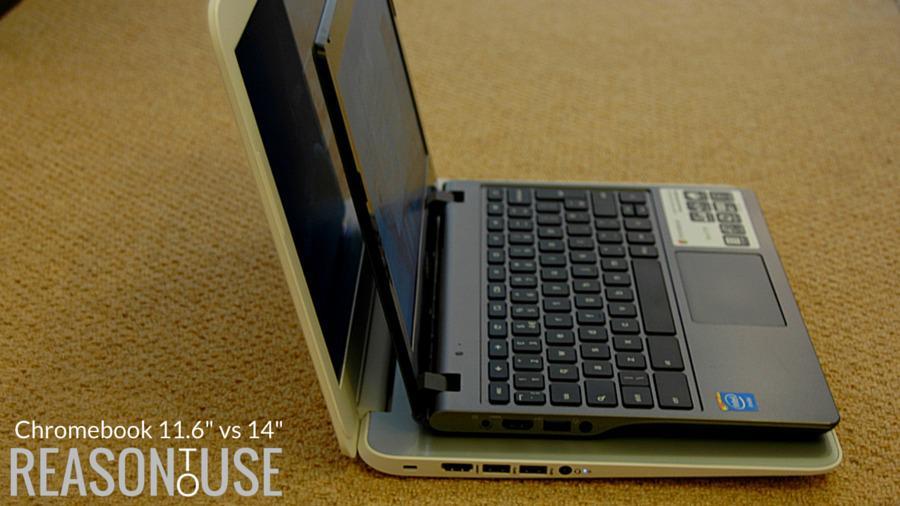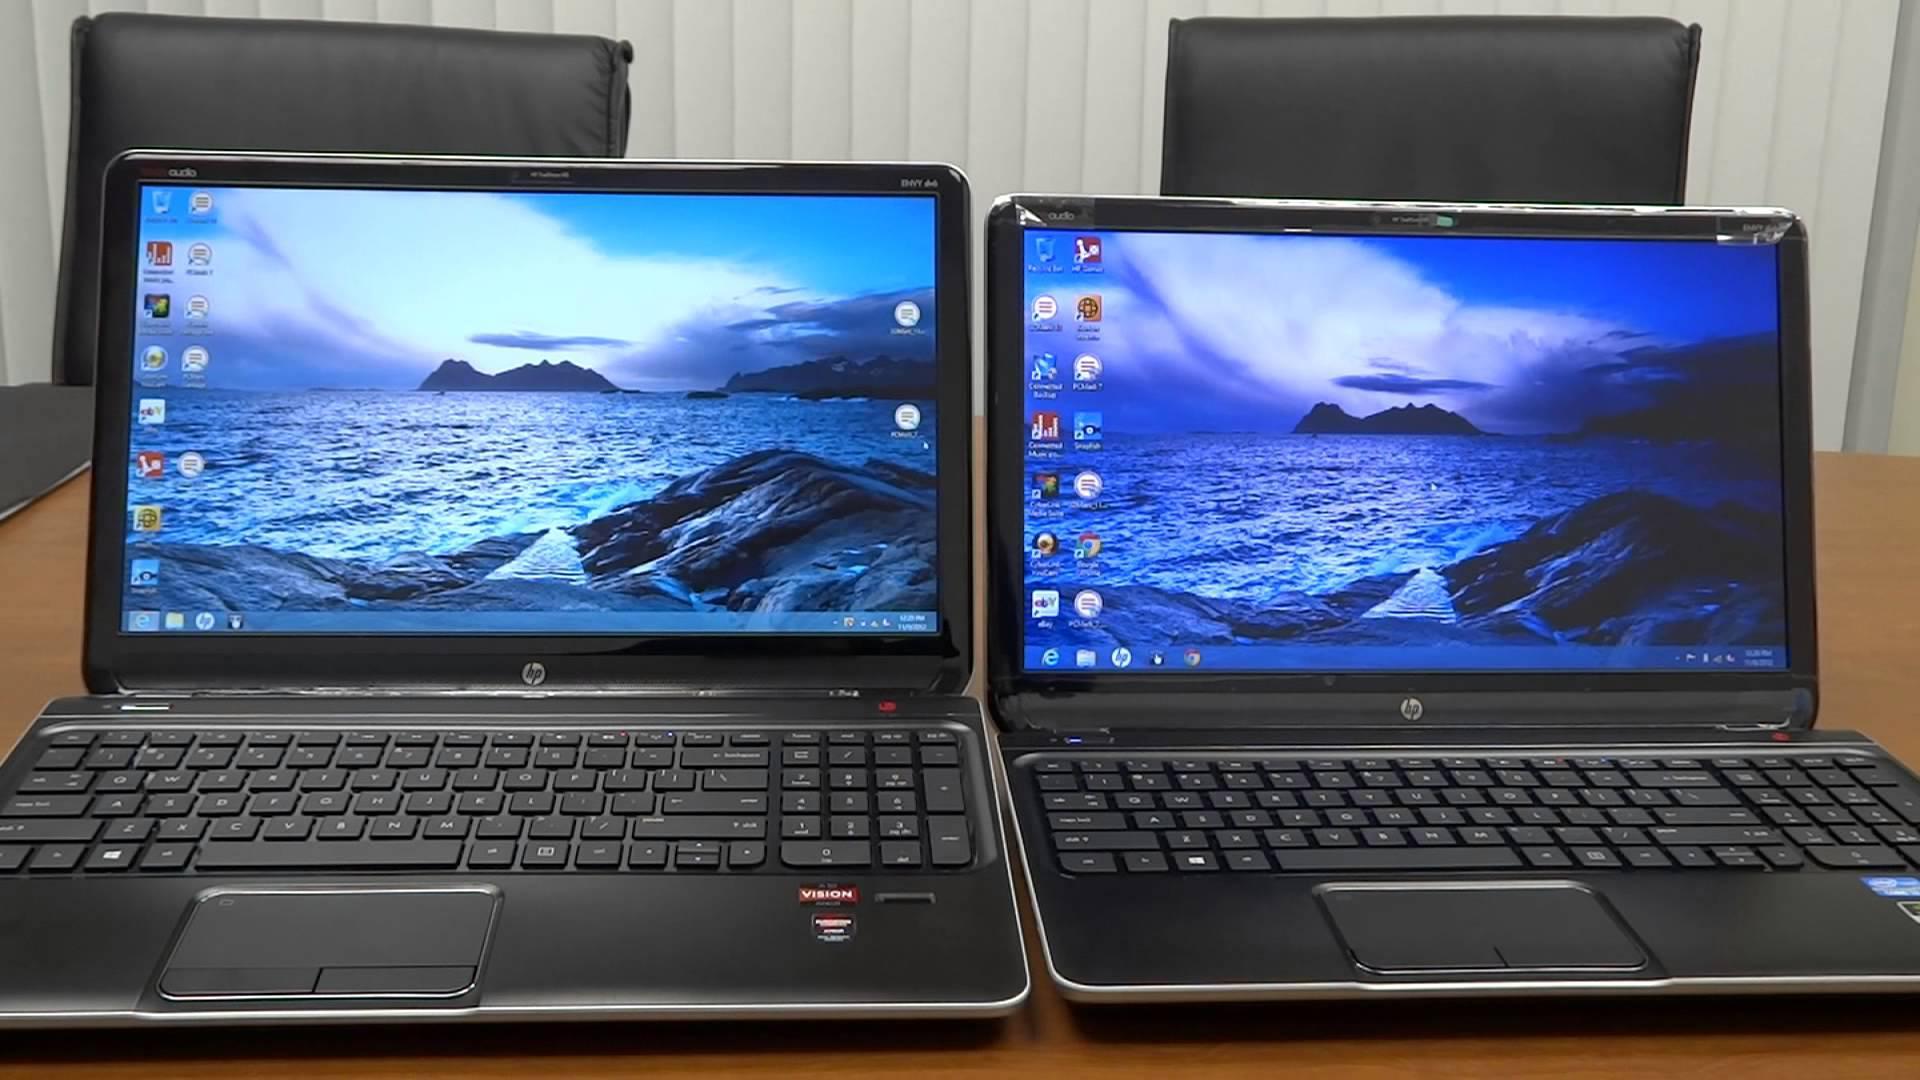The first image is the image on the left, the second image is the image on the right. Analyze the images presented: Is the assertion "One image shows side by side open laptops, and the other shows a small laptop resting on top of a bigger one." valid? Answer yes or no. Yes. The first image is the image on the left, the second image is the image on the right. Evaluate the accuracy of this statement regarding the images: "Exactly two open laptops can be seen on the image on the right.". Is it true? Answer yes or no. Yes. 